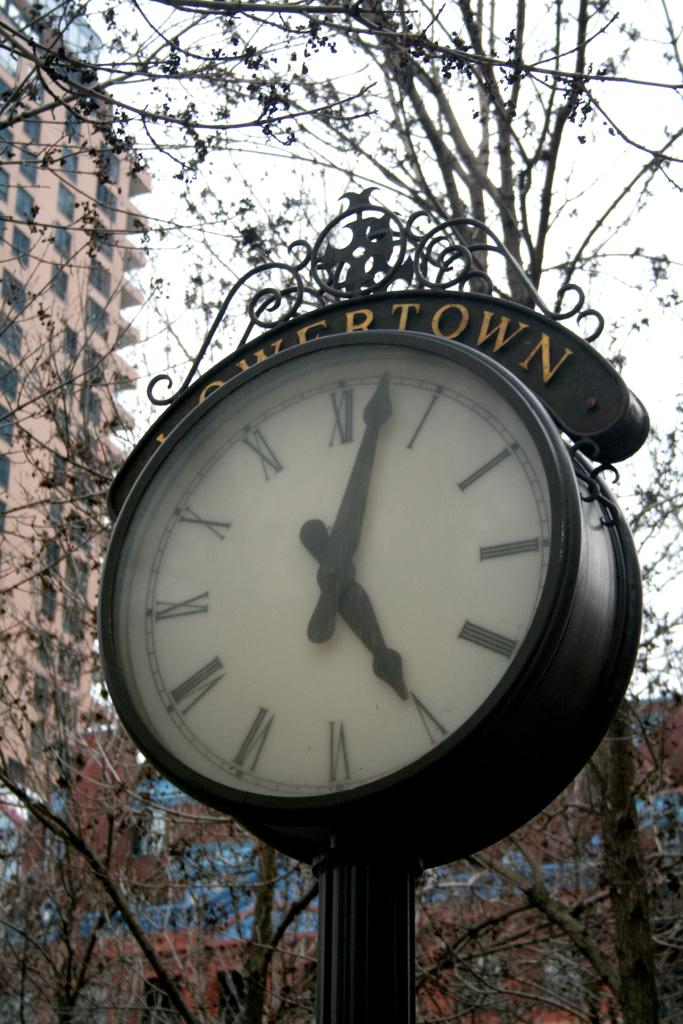Provide a one-sentence caption for the provided image. A clock in the middle of a city says Lowertown on it. 